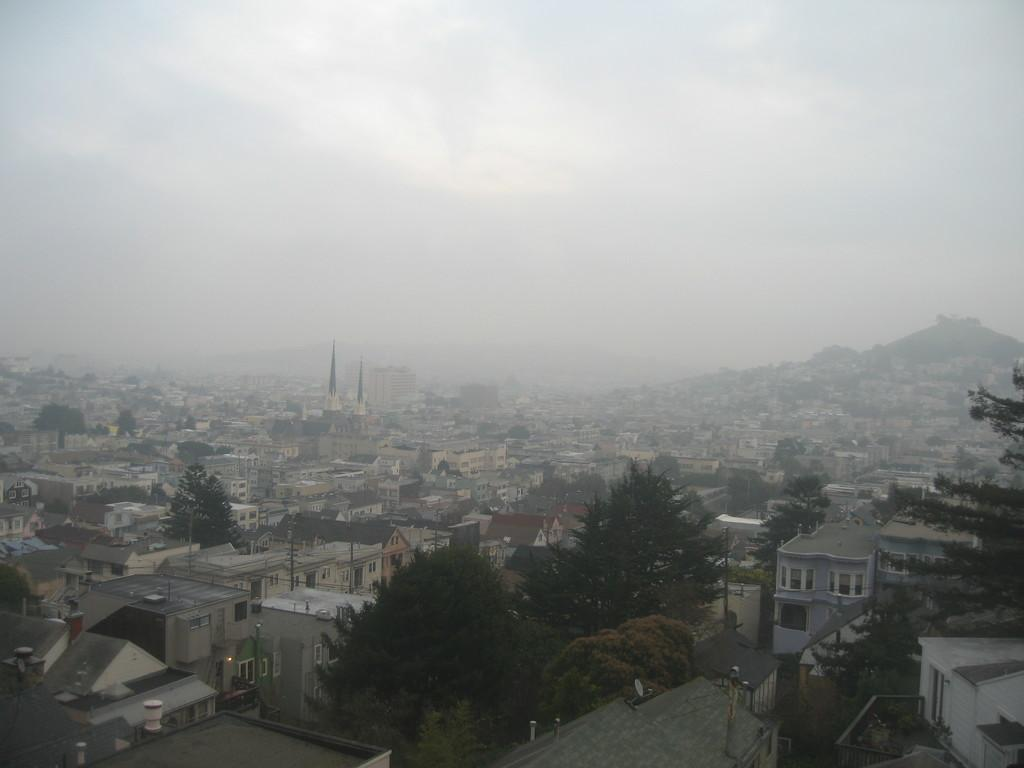What type of structures can be seen in the image? There are many buildings with windows in the image. What type of vegetation is present in the image? There are trees in the image. What other objects can be seen in the image? There are poles in the image. What can be seen in the background of the image? Hills and the sky are visible in the background. What is the condition of the sky in the image? Clouds are present in the sky. What statement does the creator of the image make about the trees in the image? There is no creator of the image mentioned, and therefore no statement can be attributed to them about the trees. 